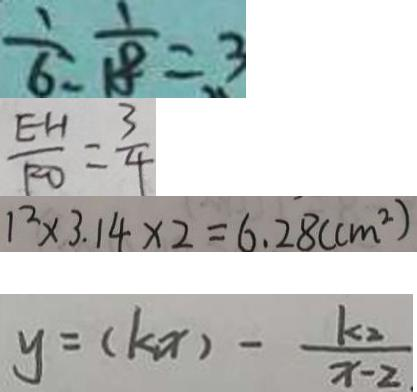<formula> <loc_0><loc_0><loc_500><loc_500>\frac { 1 } { 6 } : \frac { 1 } { 1 8 } = 3 
 \frac { E H } { F O } = \frac { 3 } { 4 } 
 1 ^ { 2 } \times 3 . 1 4 \times 2 = 6 . 2 8 ( c m ^ { 2 } ) 
 y = ( k x ) - \frac { k _ { 2 } } { x - 2 }</formula> 